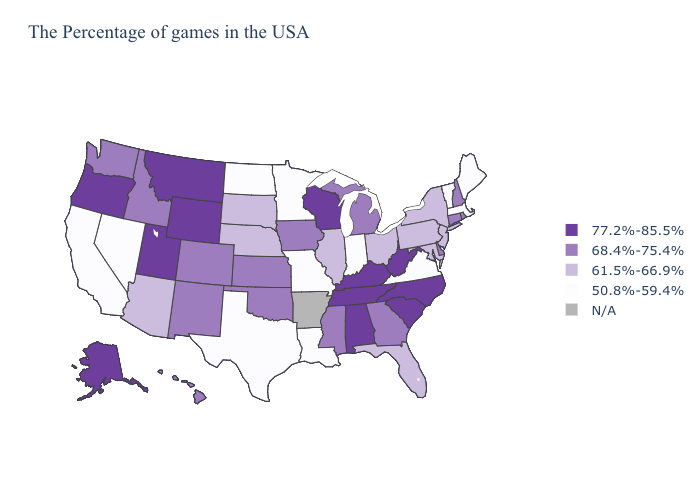How many symbols are there in the legend?
Keep it brief. 5. Name the states that have a value in the range 61.5%-66.9%?
Quick response, please. New York, New Jersey, Maryland, Pennsylvania, Ohio, Florida, Illinois, Nebraska, South Dakota, Arizona. Does Connecticut have the highest value in the USA?
Concise answer only. No. What is the value of Tennessee?
Answer briefly. 77.2%-85.5%. Name the states that have a value in the range 77.2%-85.5%?
Be succinct. North Carolina, South Carolina, West Virginia, Kentucky, Alabama, Tennessee, Wisconsin, Wyoming, Utah, Montana, Oregon, Alaska. What is the value of Hawaii?
Quick response, please. 68.4%-75.4%. What is the highest value in the USA?
Short answer required. 77.2%-85.5%. Does the map have missing data?
Answer briefly. Yes. Which states have the lowest value in the West?
Short answer required. Nevada, California. Which states have the highest value in the USA?
Quick response, please. North Carolina, South Carolina, West Virginia, Kentucky, Alabama, Tennessee, Wisconsin, Wyoming, Utah, Montana, Oregon, Alaska. What is the value of Colorado?
Quick response, please. 68.4%-75.4%. What is the value of Kentucky?
Quick response, please. 77.2%-85.5%. 